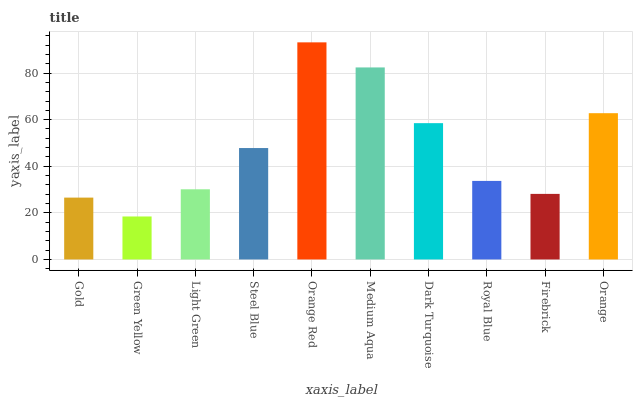Is Light Green the minimum?
Answer yes or no. No. Is Light Green the maximum?
Answer yes or no. No. Is Light Green greater than Green Yellow?
Answer yes or no. Yes. Is Green Yellow less than Light Green?
Answer yes or no. Yes. Is Green Yellow greater than Light Green?
Answer yes or no. No. Is Light Green less than Green Yellow?
Answer yes or no. No. Is Steel Blue the high median?
Answer yes or no. Yes. Is Royal Blue the low median?
Answer yes or no. Yes. Is Orange Red the high median?
Answer yes or no. No. Is Dark Turquoise the low median?
Answer yes or no. No. 